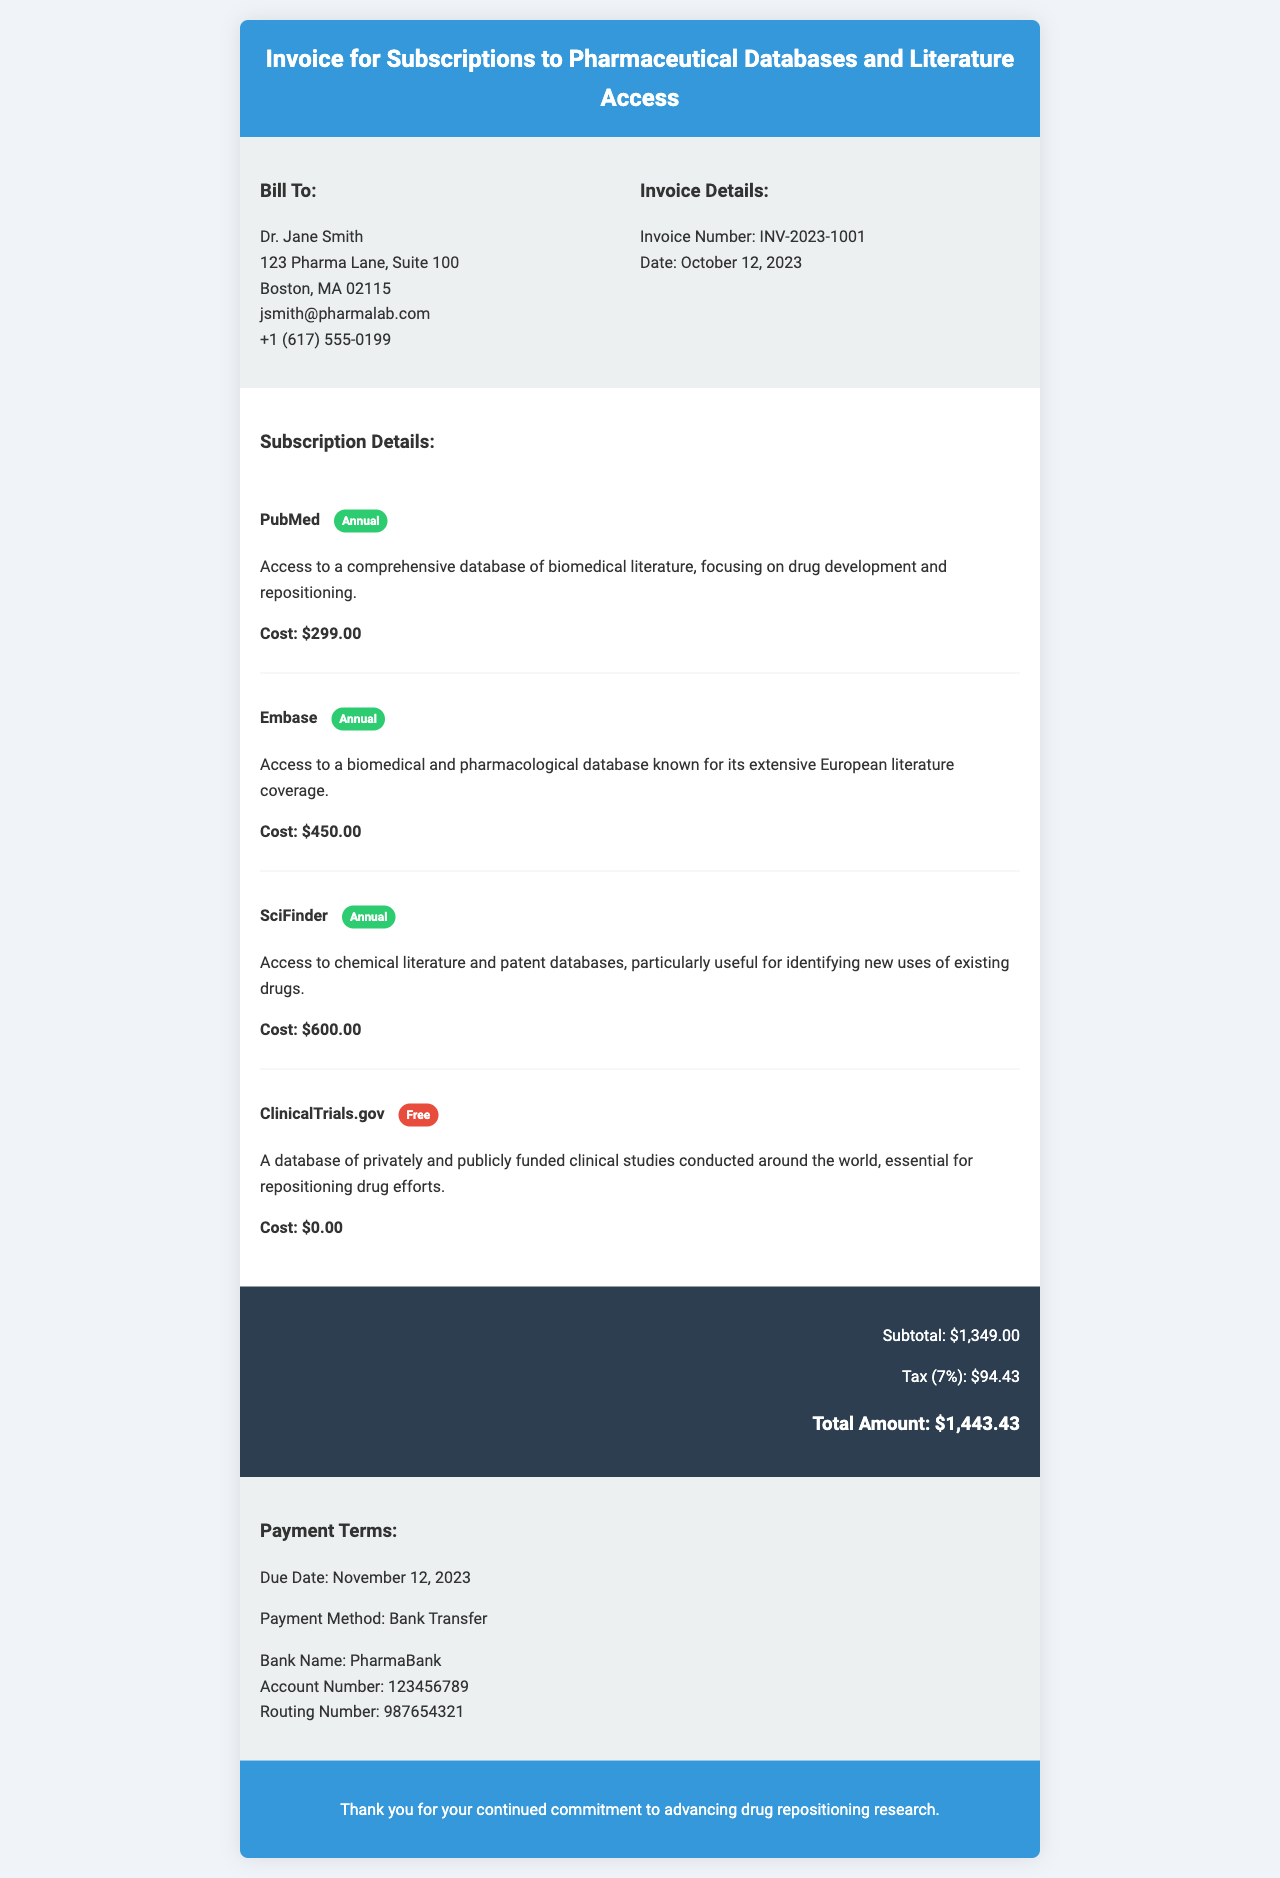What is the invoice number? The invoice number is presented in the invoice details section, which specifies the identification for this particular invoice.
Answer: INV-2023-1001 Who is the billed recipient? The bill-to section identifies the individual or organization to whom the invoice is addressed.
Answer: Dr. Jane Smith What is the due date for payment? The due date for payment is provided in the payment terms section of the document.
Answer: November 12, 2023 What is the total amount due? The total amount due is calculated from the subtotal and tax listed at the bottom of the invoice.
Answer: $1,443.43 Which subscription has a cost of zero? The subscription details list each service and its associated cost.
Answer: ClinicalTrials.gov What is the cost of SciFinder? The subscription details state the price for each service, including SciFinder, in the invoice.
Answer: $600.00 How much is the tax applied? The total amount of tax is provided in the total section, showing additional charges on the subtotal.
Answer: $94.43 What payment method is specified? The payment terms section outlines how the payment should be processed by specifying the method accepted.
Answer: Bank Transfer What is the total cost before tax? The subtotal section lists the total cost before tax is applied to the subscription services.
Answer: $1,349.00 